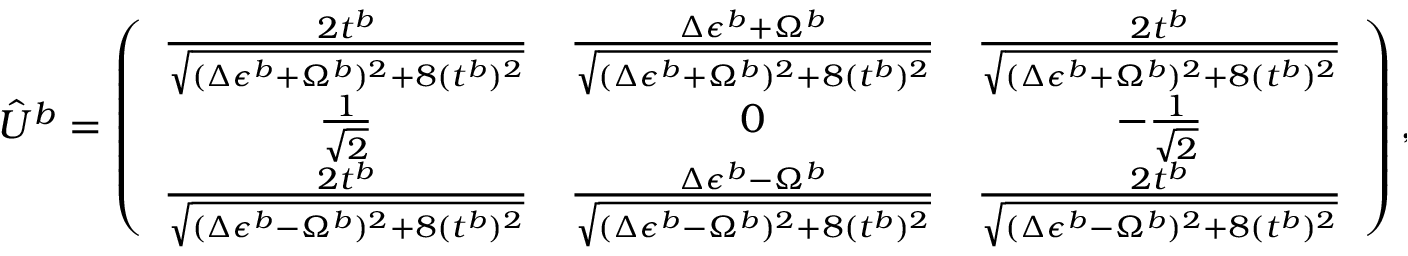Convert formula to latex. <formula><loc_0><loc_0><loc_500><loc_500>\hat { U } ^ { b } = \left ( \begin{array} { c c c } { \frac { 2 t ^ { b } } { \sqrt { ( \Delta \epsilon ^ { b } + \Omega ^ { b } ) ^ { 2 } + 8 ( t ^ { b } ) ^ { 2 } } } } & { \frac { \Delta \epsilon ^ { b } + \Omega ^ { b } } { \sqrt { ( \Delta \epsilon ^ { b } + \Omega ^ { b } ) ^ { 2 } + 8 ( t ^ { b } ) ^ { 2 } } } } & { \frac { 2 t ^ { b } } { \sqrt { ( \Delta \epsilon ^ { b } + \Omega ^ { b } ) ^ { 2 } + 8 ( t ^ { b } ) ^ { 2 } } } } \\ { \frac { 1 } { \sqrt { 2 } } } & { 0 } & { - \frac { 1 } { \sqrt { 2 } } } \\ { \frac { 2 t ^ { b } } { \sqrt { ( \Delta \epsilon ^ { b } - \Omega ^ { b } ) ^ { 2 } + 8 ( t ^ { b } ) ^ { 2 } } } } & { \frac { \Delta \epsilon ^ { b } - \Omega ^ { b } } { \sqrt { ( \Delta \epsilon ^ { b } - \Omega ^ { b } ) ^ { 2 } + 8 ( t ^ { b } ) ^ { 2 } } } } & { \frac { 2 t ^ { b } } { \sqrt { ( \Delta \epsilon ^ { b } - \Omega ^ { b } ) ^ { 2 } + 8 ( t ^ { b } ) ^ { 2 } } } } \end{array} \right ) ,</formula> 